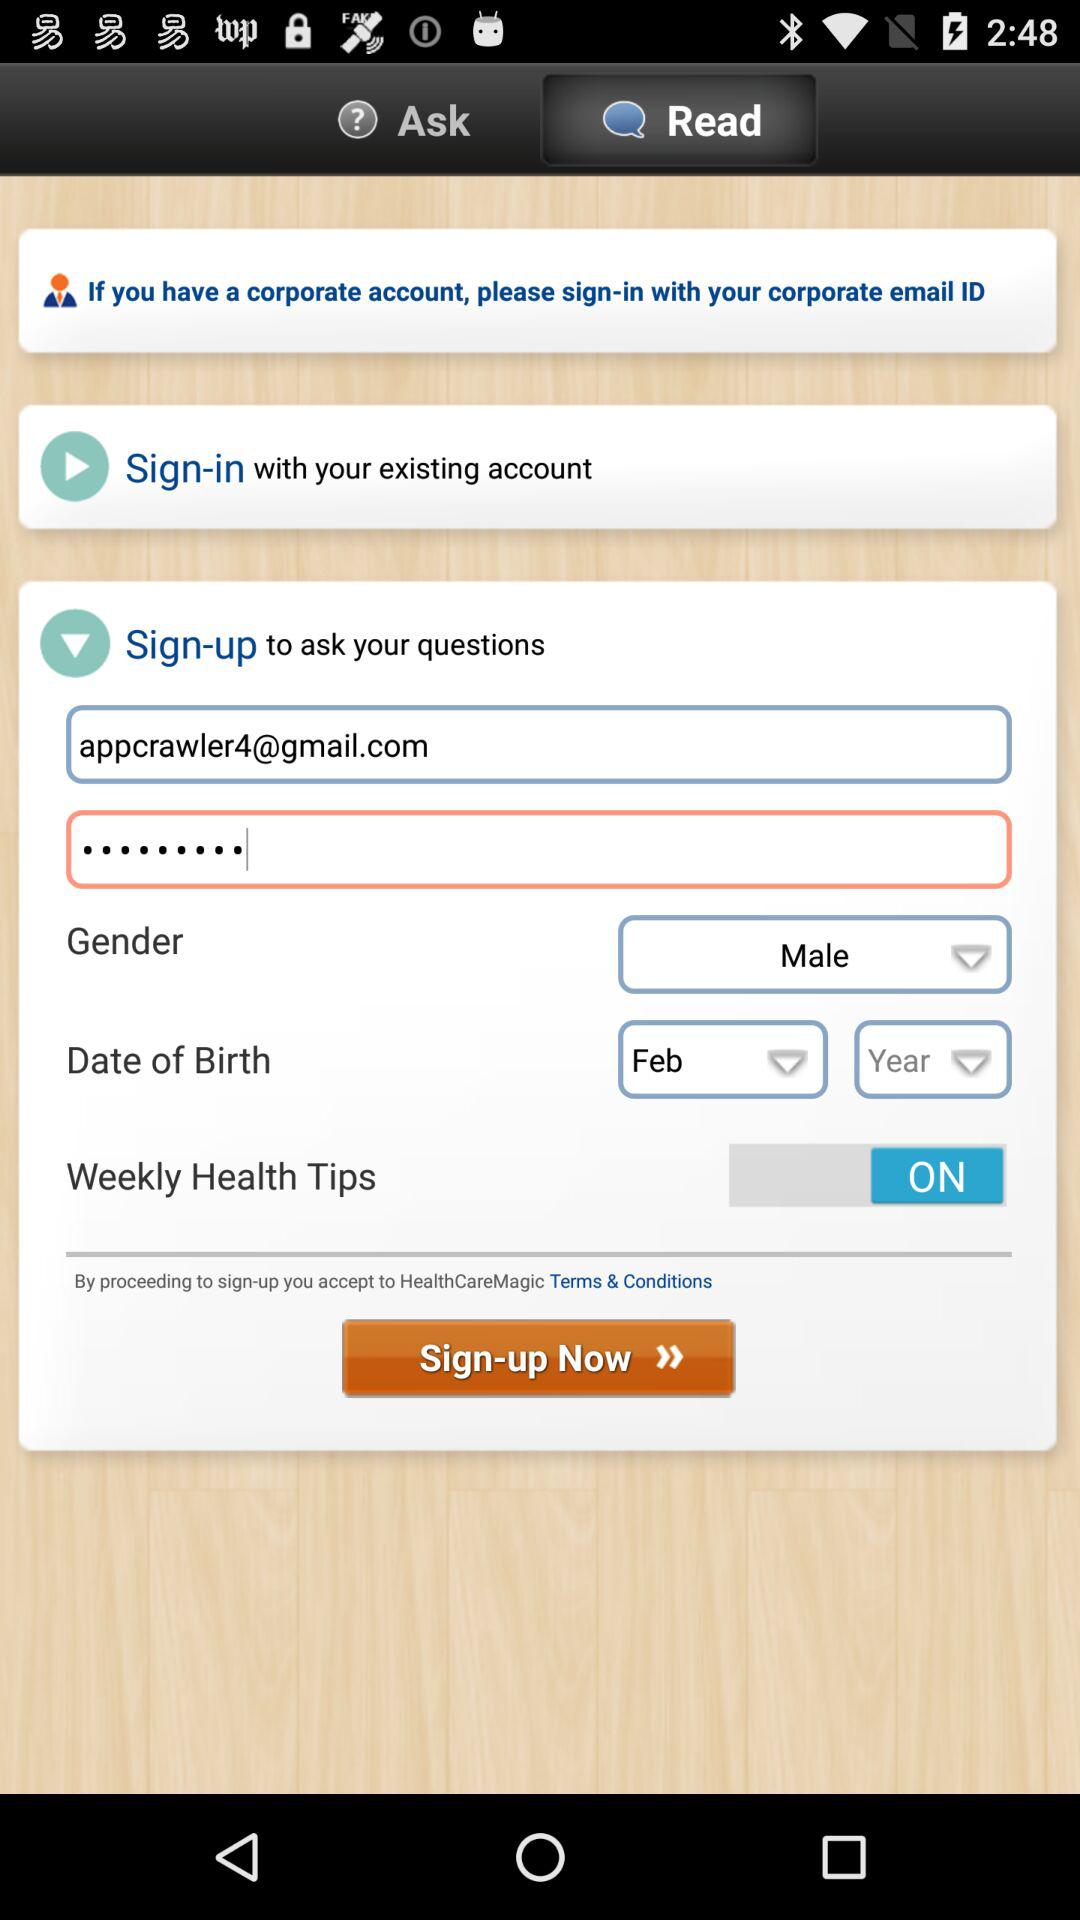What is the status of "Weekly Health Tips"? The status is "on". 